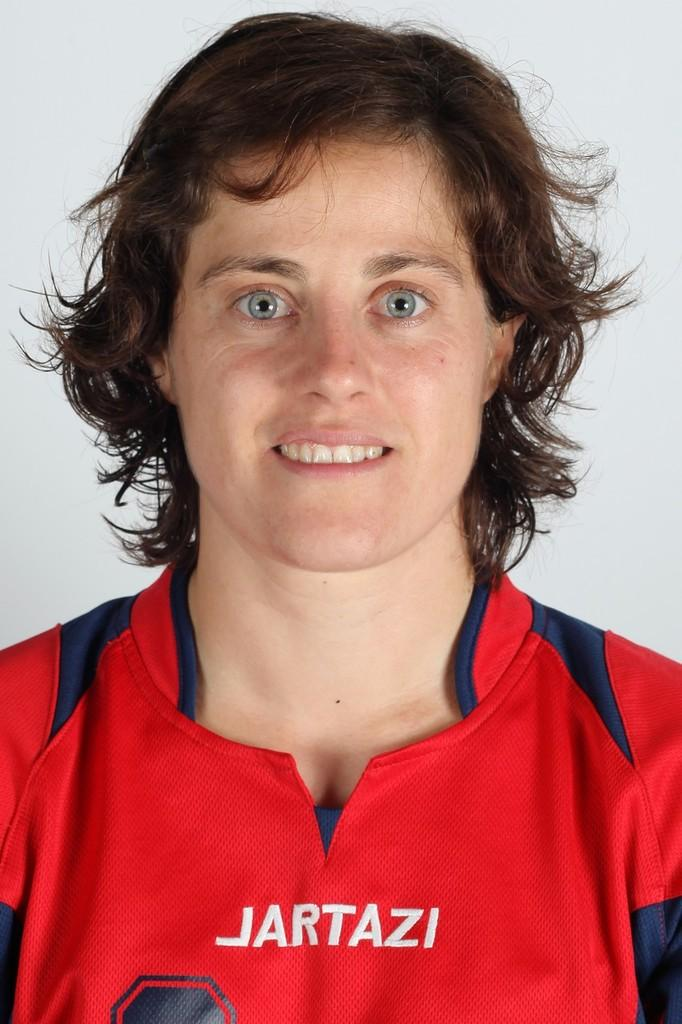Provide a one-sentence caption for the provided image. Woman wearing a red jersey which says JARTAZI. 